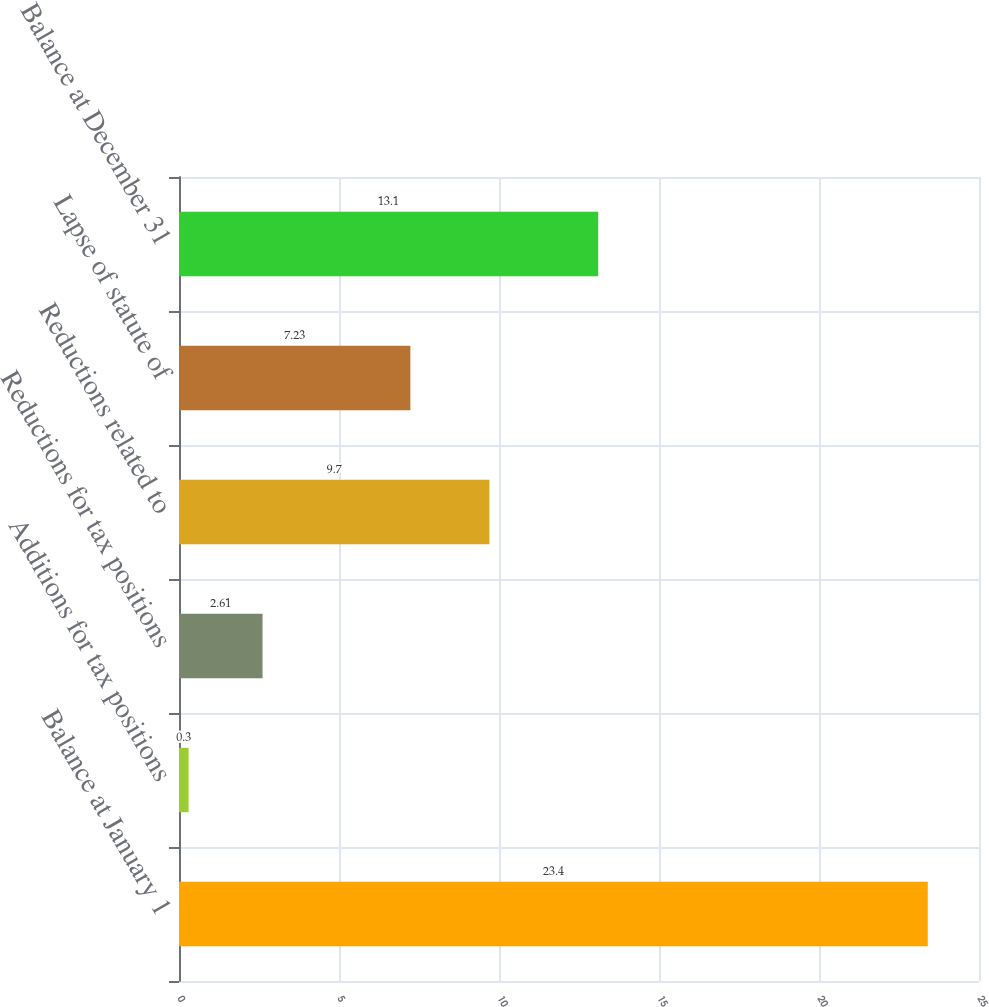Convert chart to OTSL. <chart><loc_0><loc_0><loc_500><loc_500><bar_chart><fcel>Balance at January 1<fcel>Additions for tax positions<fcel>Reductions for tax positions<fcel>Reductions related to<fcel>Lapse of statute of<fcel>Balance at December 31<nl><fcel>23.4<fcel>0.3<fcel>2.61<fcel>9.7<fcel>7.23<fcel>13.1<nl></chart> 